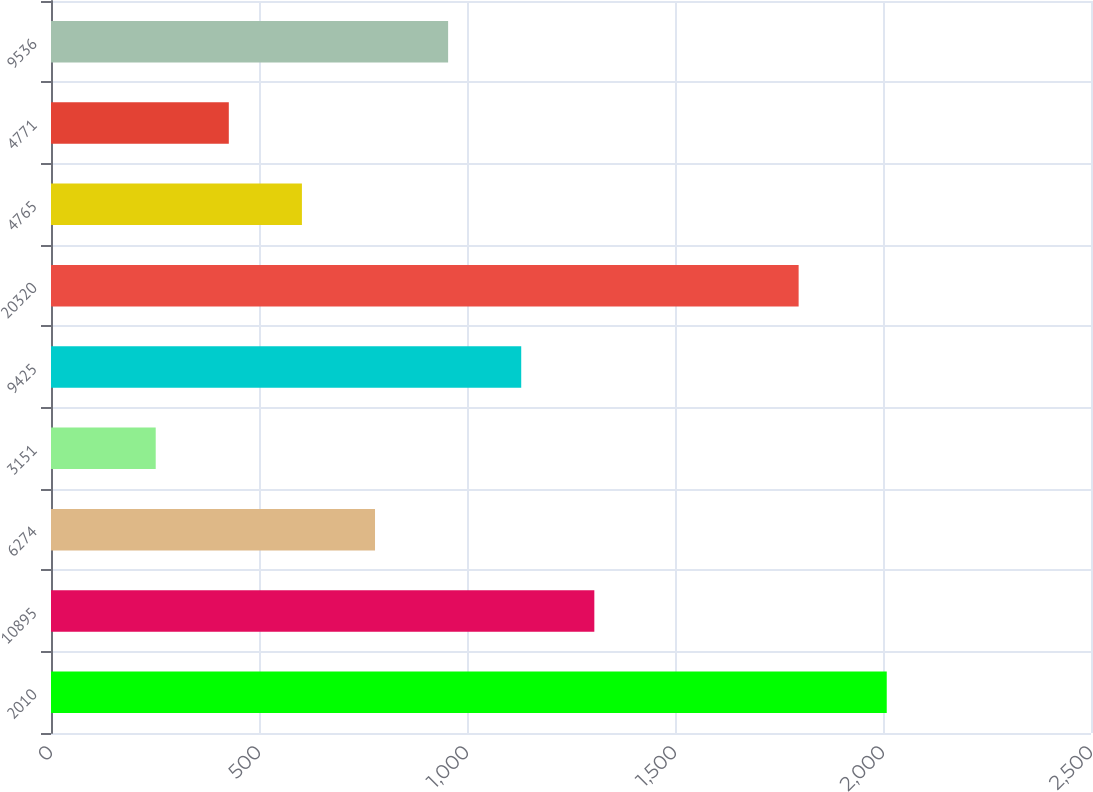<chart> <loc_0><loc_0><loc_500><loc_500><bar_chart><fcel>2010<fcel>10895<fcel>6274<fcel>3151<fcel>9425<fcel>20320<fcel>4765<fcel>4771<fcel>9536<nl><fcel>2009<fcel>1306.08<fcel>778.89<fcel>251.7<fcel>1130.35<fcel>1797.2<fcel>603.16<fcel>427.43<fcel>954.62<nl></chart> 